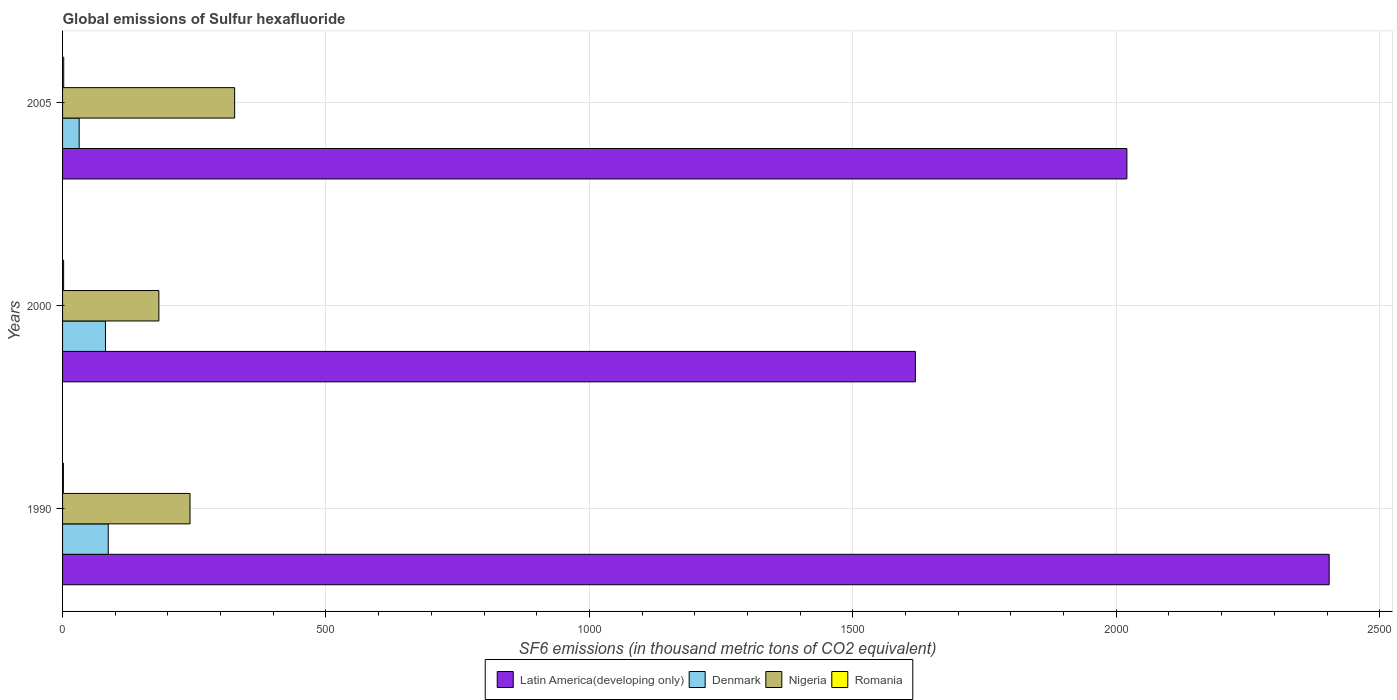How many groups of bars are there?
Provide a short and direct response. 3. Are the number of bars on each tick of the Y-axis equal?
Provide a short and direct response. Yes. How many bars are there on the 2nd tick from the top?
Your answer should be compact. 4. What is the global emissions of Sulfur hexafluoride in Romania in 2005?
Keep it short and to the point. 2.2. Across all years, what is the maximum global emissions of Sulfur hexafluoride in Latin America(developing only)?
Make the answer very short. 2404.1. In which year was the global emissions of Sulfur hexafluoride in Latin America(developing only) maximum?
Offer a very short reply. 1990. What is the total global emissions of Sulfur hexafluoride in Romania in the graph?
Provide a short and direct response. 5.8. What is the difference between the global emissions of Sulfur hexafluoride in Latin America(developing only) in 1990 and that in 2000?
Ensure brevity in your answer.  785.4. What is the difference between the global emissions of Sulfur hexafluoride in Denmark in 1990 and the global emissions of Sulfur hexafluoride in Latin America(developing only) in 2000?
Provide a succinct answer. -1532. What is the average global emissions of Sulfur hexafluoride in Romania per year?
Your answer should be very brief. 1.93. In the year 2005, what is the difference between the global emissions of Sulfur hexafluoride in Nigeria and global emissions of Sulfur hexafluoride in Romania?
Your answer should be very brief. 324.4. In how many years, is the global emissions of Sulfur hexafluoride in Nigeria greater than 500 thousand metric tons?
Ensure brevity in your answer.  0. What is the ratio of the global emissions of Sulfur hexafluoride in Nigeria in 1990 to that in 2005?
Give a very brief answer. 0.74. Is the global emissions of Sulfur hexafluoride in Nigeria in 1990 less than that in 2000?
Ensure brevity in your answer.  No. What is the difference between the highest and the second highest global emissions of Sulfur hexafluoride in Nigeria?
Offer a terse response. 84.7. What is the difference between the highest and the lowest global emissions of Sulfur hexafluoride in Romania?
Make the answer very short. 0.6. What does the 1st bar from the top in 1990 represents?
Your answer should be compact. Romania. What does the 1st bar from the bottom in 1990 represents?
Provide a succinct answer. Latin America(developing only). Is it the case that in every year, the sum of the global emissions of Sulfur hexafluoride in Denmark and global emissions of Sulfur hexafluoride in Romania is greater than the global emissions of Sulfur hexafluoride in Latin America(developing only)?
Keep it short and to the point. No. How many years are there in the graph?
Keep it short and to the point. 3. Are the values on the major ticks of X-axis written in scientific E-notation?
Offer a very short reply. No. How many legend labels are there?
Your response must be concise. 4. What is the title of the graph?
Provide a short and direct response. Global emissions of Sulfur hexafluoride. Does "Serbia" appear as one of the legend labels in the graph?
Keep it short and to the point. No. What is the label or title of the X-axis?
Provide a succinct answer. SF6 emissions (in thousand metric tons of CO2 equivalent). What is the label or title of the Y-axis?
Offer a very short reply. Years. What is the SF6 emissions (in thousand metric tons of CO2 equivalent) in Latin America(developing only) in 1990?
Provide a short and direct response. 2404.1. What is the SF6 emissions (in thousand metric tons of CO2 equivalent) of Denmark in 1990?
Make the answer very short. 86.7. What is the SF6 emissions (in thousand metric tons of CO2 equivalent) of Nigeria in 1990?
Provide a succinct answer. 241.9. What is the SF6 emissions (in thousand metric tons of CO2 equivalent) of Latin America(developing only) in 2000?
Keep it short and to the point. 1618.7. What is the SF6 emissions (in thousand metric tons of CO2 equivalent) of Denmark in 2000?
Your answer should be very brief. 81.4. What is the SF6 emissions (in thousand metric tons of CO2 equivalent) of Nigeria in 2000?
Make the answer very short. 182.8. What is the SF6 emissions (in thousand metric tons of CO2 equivalent) of Romania in 2000?
Your answer should be very brief. 2. What is the SF6 emissions (in thousand metric tons of CO2 equivalent) of Latin America(developing only) in 2005?
Make the answer very short. 2020.16. What is the SF6 emissions (in thousand metric tons of CO2 equivalent) of Denmark in 2005?
Your answer should be very brief. 31.5. What is the SF6 emissions (in thousand metric tons of CO2 equivalent) in Nigeria in 2005?
Make the answer very short. 326.6. What is the SF6 emissions (in thousand metric tons of CO2 equivalent) of Romania in 2005?
Your response must be concise. 2.2. Across all years, what is the maximum SF6 emissions (in thousand metric tons of CO2 equivalent) in Latin America(developing only)?
Ensure brevity in your answer.  2404.1. Across all years, what is the maximum SF6 emissions (in thousand metric tons of CO2 equivalent) in Denmark?
Keep it short and to the point. 86.7. Across all years, what is the maximum SF6 emissions (in thousand metric tons of CO2 equivalent) of Nigeria?
Ensure brevity in your answer.  326.6. Across all years, what is the minimum SF6 emissions (in thousand metric tons of CO2 equivalent) of Latin America(developing only)?
Give a very brief answer. 1618.7. Across all years, what is the minimum SF6 emissions (in thousand metric tons of CO2 equivalent) in Denmark?
Give a very brief answer. 31.5. Across all years, what is the minimum SF6 emissions (in thousand metric tons of CO2 equivalent) in Nigeria?
Give a very brief answer. 182.8. What is the total SF6 emissions (in thousand metric tons of CO2 equivalent) in Latin America(developing only) in the graph?
Give a very brief answer. 6042.96. What is the total SF6 emissions (in thousand metric tons of CO2 equivalent) of Denmark in the graph?
Your response must be concise. 199.6. What is the total SF6 emissions (in thousand metric tons of CO2 equivalent) in Nigeria in the graph?
Give a very brief answer. 751.3. What is the total SF6 emissions (in thousand metric tons of CO2 equivalent) in Romania in the graph?
Provide a succinct answer. 5.8. What is the difference between the SF6 emissions (in thousand metric tons of CO2 equivalent) of Latin America(developing only) in 1990 and that in 2000?
Your answer should be compact. 785.4. What is the difference between the SF6 emissions (in thousand metric tons of CO2 equivalent) of Nigeria in 1990 and that in 2000?
Offer a very short reply. 59.1. What is the difference between the SF6 emissions (in thousand metric tons of CO2 equivalent) of Romania in 1990 and that in 2000?
Offer a very short reply. -0.4. What is the difference between the SF6 emissions (in thousand metric tons of CO2 equivalent) of Latin America(developing only) in 1990 and that in 2005?
Your response must be concise. 383.94. What is the difference between the SF6 emissions (in thousand metric tons of CO2 equivalent) in Denmark in 1990 and that in 2005?
Make the answer very short. 55.2. What is the difference between the SF6 emissions (in thousand metric tons of CO2 equivalent) in Nigeria in 1990 and that in 2005?
Provide a succinct answer. -84.7. What is the difference between the SF6 emissions (in thousand metric tons of CO2 equivalent) of Romania in 1990 and that in 2005?
Your answer should be compact. -0.6. What is the difference between the SF6 emissions (in thousand metric tons of CO2 equivalent) in Latin America(developing only) in 2000 and that in 2005?
Offer a terse response. -401.46. What is the difference between the SF6 emissions (in thousand metric tons of CO2 equivalent) of Denmark in 2000 and that in 2005?
Ensure brevity in your answer.  49.9. What is the difference between the SF6 emissions (in thousand metric tons of CO2 equivalent) in Nigeria in 2000 and that in 2005?
Offer a terse response. -143.8. What is the difference between the SF6 emissions (in thousand metric tons of CO2 equivalent) of Romania in 2000 and that in 2005?
Your response must be concise. -0.2. What is the difference between the SF6 emissions (in thousand metric tons of CO2 equivalent) in Latin America(developing only) in 1990 and the SF6 emissions (in thousand metric tons of CO2 equivalent) in Denmark in 2000?
Ensure brevity in your answer.  2322.7. What is the difference between the SF6 emissions (in thousand metric tons of CO2 equivalent) in Latin America(developing only) in 1990 and the SF6 emissions (in thousand metric tons of CO2 equivalent) in Nigeria in 2000?
Your response must be concise. 2221.3. What is the difference between the SF6 emissions (in thousand metric tons of CO2 equivalent) of Latin America(developing only) in 1990 and the SF6 emissions (in thousand metric tons of CO2 equivalent) of Romania in 2000?
Ensure brevity in your answer.  2402.1. What is the difference between the SF6 emissions (in thousand metric tons of CO2 equivalent) in Denmark in 1990 and the SF6 emissions (in thousand metric tons of CO2 equivalent) in Nigeria in 2000?
Make the answer very short. -96.1. What is the difference between the SF6 emissions (in thousand metric tons of CO2 equivalent) in Denmark in 1990 and the SF6 emissions (in thousand metric tons of CO2 equivalent) in Romania in 2000?
Offer a terse response. 84.7. What is the difference between the SF6 emissions (in thousand metric tons of CO2 equivalent) in Nigeria in 1990 and the SF6 emissions (in thousand metric tons of CO2 equivalent) in Romania in 2000?
Give a very brief answer. 239.9. What is the difference between the SF6 emissions (in thousand metric tons of CO2 equivalent) of Latin America(developing only) in 1990 and the SF6 emissions (in thousand metric tons of CO2 equivalent) of Denmark in 2005?
Your answer should be very brief. 2372.6. What is the difference between the SF6 emissions (in thousand metric tons of CO2 equivalent) in Latin America(developing only) in 1990 and the SF6 emissions (in thousand metric tons of CO2 equivalent) in Nigeria in 2005?
Offer a very short reply. 2077.5. What is the difference between the SF6 emissions (in thousand metric tons of CO2 equivalent) of Latin America(developing only) in 1990 and the SF6 emissions (in thousand metric tons of CO2 equivalent) of Romania in 2005?
Give a very brief answer. 2401.9. What is the difference between the SF6 emissions (in thousand metric tons of CO2 equivalent) of Denmark in 1990 and the SF6 emissions (in thousand metric tons of CO2 equivalent) of Nigeria in 2005?
Your answer should be very brief. -239.9. What is the difference between the SF6 emissions (in thousand metric tons of CO2 equivalent) in Denmark in 1990 and the SF6 emissions (in thousand metric tons of CO2 equivalent) in Romania in 2005?
Offer a very short reply. 84.5. What is the difference between the SF6 emissions (in thousand metric tons of CO2 equivalent) in Nigeria in 1990 and the SF6 emissions (in thousand metric tons of CO2 equivalent) in Romania in 2005?
Keep it short and to the point. 239.7. What is the difference between the SF6 emissions (in thousand metric tons of CO2 equivalent) in Latin America(developing only) in 2000 and the SF6 emissions (in thousand metric tons of CO2 equivalent) in Denmark in 2005?
Offer a terse response. 1587.2. What is the difference between the SF6 emissions (in thousand metric tons of CO2 equivalent) in Latin America(developing only) in 2000 and the SF6 emissions (in thousand metric tons of CO2 equivalent) in Nigeria in 2005?
Your answer should be very brief. 1292.1. What is the difference between the SF6 emissions (in thousand metric tons of CO2 equivalent) in Latin America(developing only) in 2000 and the SF6 emissions (in thousand metric tons of CO2 equivalent) in Romania in 2005?
Provide a succinct answer. 1616.5. What is the difference between the SF6 emissions (in thousand metric tons of CO2 equivalent) of Denmark in 2000 and the SF6 emissions (in thousand metric tons of CO2 equivalent) of Nigeria in 2005?
Make the answer very short. -245.2. What is the difference between the SF6 emissions (in thousand metric tons of CO2 equivalent) of Denmark in 2000 and the SF6 emissions (in thousand metric tons of CO2 equivalent) of Romania in 2005?
Your answer should be compact. 79.2. What is the difference between the SF6 emissions (in thousand metric tons of CO2 equivalent) in Nigeria in 2000 and the SF6 emissions (in thousand metric tons of CO2 equivalent) in Romania in 2005?
Offer a terse response. 180.6. What is the average SF6 emissions (in thousand metric tons of CO2 equivalent) of Latin America(developing only) per year?
Provide a short and direct response. 2014.32. What is the average SF6 emissions (in thousand metric tons of CO2 equivalent) of Denmark per year?
Offer a terse response. 66.53. What is the average SF6 emissions (in thousand metric tons of CO2 equivalent) of Nigeria per year?
Provide a succinct answer. 250.43. What is the average SF6 emissions (in thousand metric tons of CO2 equivalent) of Romania per year?
Give a very brief answer. 1.93. In the year 1990, what is the difference between the SF6 emissions (in thousand metric tons of CO2 equivalent) in Latin America(developing only) and SF6 emissions (in thousand metric tons of CO2 equivalent) in Denmark?
Provide a succinct answer. 2317.4. In the year 1990, what is the difference between the SF6 emissions (in thousand metric tons of CO2 equivalent) of Latin America(developing only) and SF6 emissions (in thousand metric tons of CO2 equivalent) of Nigeria?
Keep it short and to the point. 2162.2. In the year 1990, what is the difference between the SF6 emissions (in thousand metric tons of CO2 equivalent) of Latin America(developing only) and SF6 emissions (in thousand metric tons of CO2 equivalent) of Romania?
Your answer should be compact. 2402.5. In the year 1990, what is the difference between the SF6 emissions (in thousand metric tons of CO2 equivalent) of Denmark and SF6 emissions (in thousand metric tons of CO2 equivalent) of Nigeria?
Provide a short and direct response. -155.2. In the year 1990, what is the difference between the SF6 emissions (in thousand metric tons of CO2 equivalent) in Denmark and SF6 emissions (in thousand metric tons of CO2 equivalent) in Romania?
Offer a terse response. 85.1. In the year 1990, what is the difference between the SF6 emissions (in thousand metric tons of CO2 equivalent) in Nigeria and SF6 emissions (in thousand metric tons of CO2 equivalent) in Romania?
Offer a very short reply. 240.3. In the year 2000, what is the difference between the SF6 emissions (in thousand metric tons of CO2 equivalent) in Latin America(developing only) and SF6 emissions (in thousand metric tons of CO2 equivalent) in Denmark?
Ensure brevity in your answer.  1537.3. In the year 2000, what is the difference between the SF6 emissions (in thousand metric tons of CO2 equivalent) of Latin America(developing only) and SF6 emissions (in thousand metric tons of CO2 equivalent) of Nigeria?
Keep it short and to the point. 1435.9. In the year 2000, what is the difference between the SF6 emissions (in thousand metric tons of CO2 equivalent) of Latin America(developing only) and SF6 emissions (in thousand metric tons of CO2 equivalent) of Romania?
Your answer should be compact. 1616.7. In the year 2000, what is the difference between the SF6 emissions (in thousand metric tons of CO2 equivalent) in Denmark and SF6 emissions (in thousand metric tons of CO2 equivalent) in Nigeria?
Your answer should be very brief. -101.4. In the year 2000, what is the difference between the SF6 emissions (in thousand metric tons of CO2 equivalent) of Denmark and SF6 emissions (in thousand metric tons of CO2 equivalent) of Romania?
Give a very brief answer. 79.4. In the year 2000, what is the difference between the SF6 emissions (in thousand metric tons of CO2 equivalent) in Nigeria and SF6 emissions (in thousand metric tons of CO2 equivalent) in Romania?
Give a very brief answer. 180.8. In the year 2005, what is the difference between the SF6 emissions (in thousand metric tons of CO2 equivalent) of Latin America(developing only) and SF6 emissions (in thousand metric tons of CO2 equivalent) of Denmark?
Your answer should be very brief. 1988.66. In the year 2005, what is the difference between the SF6 emissions (in thousand metric tons of CO2 equivalent) in Latin America(developing only) and SF6 emissions (in thousand metric tons of CO2 equivalent) in Nigeria?
Provide a succinct answer. 1693.56. In the year 2005, what is the difference between the SF6 emissions (in thousand metric tons of CO2 equivalent) of Latin America(developing only) and SF6 emissions (in thousand metric tons of CO2 equivalent) of Romania?
Provide a succinct answer. 2017.96. In the year 2005, what is the difference between the SF6 emissions (in thousand metric tons of CO2 equivalent) of Denmark and SF6 emissions (in thousand metric tons of CO2 equivalent) of Nigeria?
Offer a very short reply. -295.1. In the year 2005, what is the difference between the SF6 emissions (in thousand metric tons of CO2 equivalent) of Denmark and SF6 emissions (in thousand metric tons of CO2 equivalent) of Romania?
Your answer should be very brief. 29.3. In the year 2005, what is the difference between the SF6 emissions (in thousand metric tons of CO2 equivalent) of Nigeria and SF6 emissions (in thousand metric tons of CO2 equivalent) of Romania?
Your answer should be very brief. 324.4. What is the ratio of the SF6 emissions (in thousand metric tons of CO2 equivalent) of Latin America(developing only) in 1990 to that in 2000?
Your answer should be very brief. 1.49. What is the ratio of the SF6 emissions (in thousand metric tons of CO2 equivalent) of Denmark in 1990 to that in 2000?
Make the answer very short. 1.07. What is the ratio of the SF6 emissions (in thousand metric tons of CO2 equivalent) of Nigeria in 1990 to that in 2000?
Offer a very short reply. 1.32. What is the ratio of the SF6 emissions (in thousand metric tons of CO2 equivalent) in Latin America(developing only) in 1990 to that in 2005?
Offer a terse response. 1.19. What is the ratio of the SF6 emissions (in thousand metric tons of CO2 equivalent) in Denmark in 1990 to that in 2005?
Give a very brief answer. 2.75. What is the ratio of the SF6 emissions (in thousand metric tons of CO2 equivalent) in Nigeria in 1990 to that in 2005?
Provide a short and direct response. 0.74. What is the ratio of the SF6 emissions (in thousand metric tons of CO2 equivalent) in Romania in 1990 to that in 2005?
Give a very brief answer. 0.73. What is the ratio of the SF6 emissions (in thousand metric tons of CO2 equivalent) in Latin America(developing only) in 2000 to that in 2005?
Offer a very short reply. 0.8. What is the ratio of the SF6 emissions (in thousand metric tons of CO2 equivalent) in Denmark in 2000 to that in 2005?
Your answer should be very brief. 2.58. What is the ratio of the SF6 emissions (in thousand metric tons of CO2 equivalent) of Nigeria in 2000 to that in 2005?
Your answer should be compact. 0.56. What is the ratio of the SF6 emissions (in thousand metric tons of CO2 equivalent) in Romania in 2000 to that in 2005?
Your response must be concise. 0.91. What is the difference between the highest and the second highest SF6 emissions (in thousand metric tons of CO2 equivalent) of Latin America(developing only)?
Your answer should be very brief. 383.94. What is the difference between the highest and the second highest SF6 emissions (in thousand metric tons of CO2 equivalent) of Nigeria?
Keep it short and to the point. 84.7. What is the difference between the highest and the second highest SF6 emissions (in thousand metric tons of CO2 equivalent) of Romania?
Give a very brief answer. 0.2. What is the difference between the highest and the lowest SF6 emissions (in thousand metric tons of CO2 equivalent) of Latin America(developing only)?
Keep it short and to the point. 785.4. What is the difference between the highest and the lowest SF6 emissions (in thousand metric tons of CO2 equivalent) of Denmark?
Provide a succinct answer. 55.2. What is the difference between the highest and the lowest SF6 emissions (in thousand metric tons of CO2 equivalent) in Nigeria?
Provide a short and direct response. 143.8. What is the difference between the highest and the lowest SF6 emissions (in thousand metric tons of CO2 equivalent) in Romania?
Give a very brief answer. 0.6. 